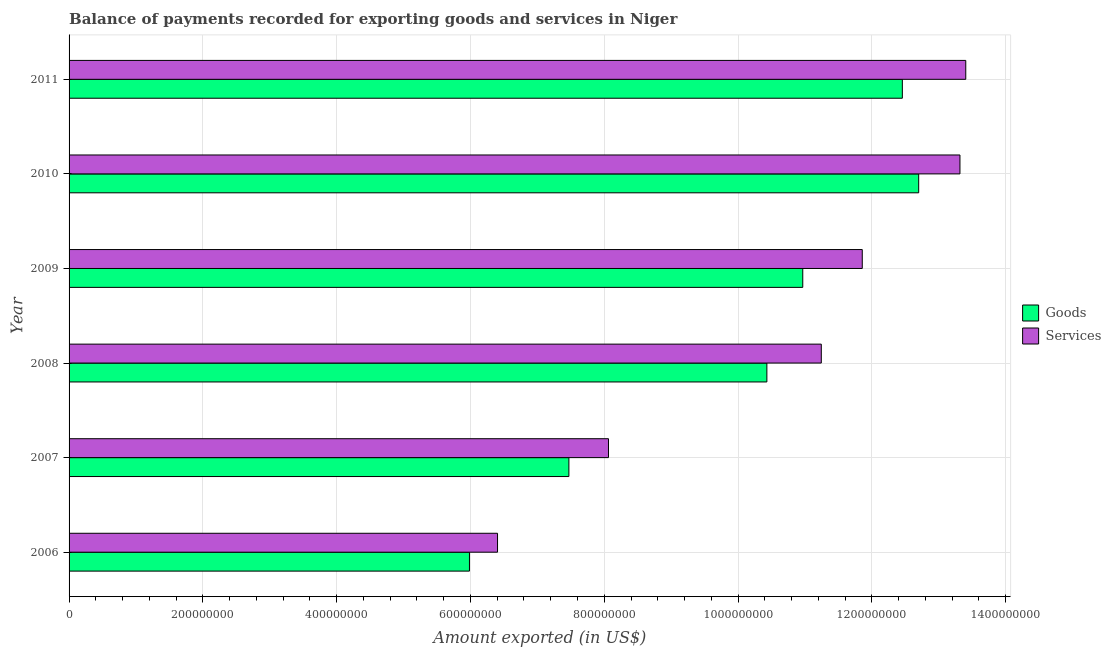How many different coloured bars are there?
Your answer should be compact. 2. How many groups of bars are there?
Your response must be concise. 6. Are the number of bars per tick equal to the number of legend labels?
Ensure brevity in your answer.  Yes. What is the amount of goods exported in 2007?
Your answer should be very brief. 7.47e+08. Across all years, what is the maximum amount of services exported?
Keep it short and to the point. 1.34e+09. Across all years, what is the minimum amount of goods exported?
Give a very brief answer. 5.99e+08. In which year was the amount of services exported minimum?
Provide a short and direct response. 2006. What is the total amount of services exported in the graph?
Give a very brief answer. 6.43e+09. What is the difference between the amount of services exported in 2007 and that in 2011?
Keep it short and to the point. -5.34e+08. What is the difference between the amount of services exported in 2006 and the amount of goods exported in 2011?
Provide a short and direct response. -6.05e+08. What is the average amount of goods exported per year?
Provide a succinct answer. 1.00e+09. In the year 2008, what is the difference between the amount of goods exported and amount of services exported?
Ensure brevity in your answer.  -8.13e+07. What is the ratio of the amount of services exported in 2007 to that in 2008?
Your answer should be very brief. 0.72. Is the difference between the amount of services exported in 2008 and 2009 greater than the difference between the amount of goods exported in 2008 and 2009?
Provide a succinct answer. No. What is the difference between the highest and the second highest amount of services exported?
Your answer should be very brief. 8.69e+06. What is the difference between the highest and the lowest amount of goods exported?
Provide a short and direct response. 6.72e+08. What does the 1st bar from the top in 2009 represents?
Provide a short and direct response. Services. What does the 1st bar from the bottom in 2009 represents?
Your answer should be very brief. Goods. How many bars are there?
Offer a very short reply. 12. Are all the bars in the graph horizontal?
Ensure brevity in your answer.  Yes. Does the graph contain any zero values?
Give a very brief answer. No. Does the graph contain grids?
Offer a very short reply. Yes. How many legend labels are there?
Provide a succinct answer. 2. What is the title of the graph?
Give a very brief answer. Balance of payments recorded for exporting goods and services in Niger. Does "Agricultural land" appear as one of the legend labels in the graph?
Give a very brief answer. No. What is the label or title of the X-axis?
Give a very brief answer. Amount exported (in US$). What is the label or title of the Y-axis?
Provide a succinct answer. Year. What is the Amount exported (in US$) of Goods in 2006?
Offer a very short reply. 5.99e+08. What is the Amount exported (in US$) of Services in 2006?
Your answer should be very brief. 6.40e+08. What is the Amount exported (in US$) in Goods in 2007?
Keep it short and to the point. 7.47e+08. What is the Amount exported (in US$) in Services in 2007?
Ensure brevity in your answer.  8.06e+08. What is the Amount exported (in US$) in Goods in 2008?
Provide a succinct answer. 1.04e+09. What is the Amount exported (in US$) in Services in 2008?
Ensure brevity in your answer.  1.12e+09. What is the Amount exported (in US$) in Goods in 2009?
Offer a very short reply. 1.10e+09. What is the Amount exported (in US$) in Services in 2009?
Your answer should be compact. 1.19e+09. What is the Amount exported (in US$) in Goods in 2010?
Provide a succinct answer. 1.27e+09. What is the Amount exported (in US$) in Services in 2010?
Your answer should be very brief. 1.33e+09. What is the Amount exported (in US$) of Goods in 2011?
Give a very brief answer. 1.25e+09. What is the Amount exported (in US$) of Services in 2011?
Offer a very short reply. 1.34e+09. Across all years, what is the maximum Amount exported (in US$) of Goods?
Ensure brevity in your answer.  1.27e+09. Across all years, what is the maximum Amount exported (in US$) in Services?
Give a very brief answer. 1.34e+09. Across all years, what is the minimum Amount exported (in US$) in Goods?
Keep it short and to the point. 5.99e+08. Across all years, what is the minimum Amount exported (in US$) of Services?
Keep it short and to the point. 6.40e+08. What is the total Amount exported (in US$) in Goods in the graph?
Offer a terse response. 6.00e+09. What is the total Amount exported (in US$) in Services in the graph?
Your answer should be compact. 6.43e+09. What is the difference between the Amount exported (in US$) of Goods in 2006 and that in 2007?
Give a very brief answer. -1.49e+08. What is the difference between the Amount exported (in US$) of Services in 2006 and that in 2007?
Offer a very short reply. -1.66e+08. What is the difference between the Amount exported (in US$) of Goods in 2006 and that in 2008?
Your answer should be very brief. -4.45e+08. What is the difference between the Amount exported (in US$) of Services in 2006 and that in 2008?
Provide a short and direct response. -4.84e+08. What is the difference between the Amount exported (in US$) in Goods in 2006 and that in 2009?
Provide a succinct answer. -4.98e+08. What is the difference between the Amount exported (in US$) of Services in 2006 and that in 2009?
Offer a very short reply. -5.45e+08. What is the difference between the Amount exported (in US$) of Goods in 2006 and that in 2010?
Your response must be concise. -6.72e+08. What is the difference between the Amount exported (in US$) of Services in 2006 and that in 2010?
Keep it short and to the point. -6.91e+08. What is the difference between the Amount exported (in US$) of Goods in 2006 and that in 2011?
Provide a succinct answer. -6.47e+08. What is the difference between the Amount exported (in US$) of Services in 2006 and that in 2011?
Your answer should be very brief. -7.00e+08. What is the difference between the Amount exported (in US$) in Goods in 2007 and that in 2008?
Offer a terse response. -2.96e+08. What is the difference between the Amount exported (in US$) of Services in 2007 and that in 2008?
Provide a succinct answer. -3.18e+08. What is the difference between the Amount exported (in US$) in Goods in 2007 and that in 2009?
Give a very brief answer. -3.50e+08. What is the difference between the Amount exported (in US$) of Services in 2007 and that in 2009?
Your response must be concise. -3.79e+08. What is the difference between the Amount exported (in US$) in Goods in 2007 and that in 2010?
Your answer should be compact. -5.23e+08. What is the difference between the Amount exported (in US$) of Services in 2007 and that in 2010?
Make the answer very short. -5.25e+08. What is the difference between the Amount exported (in US$) in Goods in 2007 and that in 2011?
Your answer should be compact. -4.98e+08. What is the difference between the Amount exported (in US$) of Services in 2007 and that in 2011?
Provide a succinct answer. -5.34e+08. What is the difference between the Amount exported (in US$) of Goods in 2008 and that in 2009?
Ensure brevity in your answer.  -5.36e+07. What is the difference between the Amount exported (in US$) of Services in 2008 and that in 2009?
Your answer should be very brief. -6.12e+07. What is the difference between the Amount exported (in US$) in Goods in 2008 and that in 2010?
Offer a very short reply. -2.27e+08. What is the difference between the Amount exported (in US$) of Services in 2008 and that in 2010?
Offer a terse response. -2.07e+08. What is the difference between the Amount exported (in US$) of Goods in 2008 and that in 2011?
Your answer should be very brief. -2.03e+08. What is the difference between the Amount exported (in US$) in Services in 2008 and that in 2011?
Make the answer very short. -2.16e+08. What is the difference between the Amount exported (in US$) of Goods in 2009 and that in 2010?
Offer a very short reply. -1.73e+08. What is the difference between the Amount exported (in US$) in Services in 2009 and that in 2010?
Ensure brevity in your answer.  -1.46e+08. What is the difference between the Amount exported (in US$) of Goods in 2009 and that in 2011?
Your response must be concise. -1.49e+08. What is the difference between the Amount exported (in US$) in Services in 2009 and that in 2011?
Make the answer very short. -1.55e+08. What is the difference between the Amount exported (in US$) of Goods in 2010 and that in 2011?
Offer a terse response. 2.44e+07. What is the difference between the Amount exported (in US$) of Services in 2010 and that in 2011?
Ensure brevity in your answer.  -8.69e+06. What is the difference between the Amount exported (in US$) in Goods in 2006 and the Amount exported (in US$) in Services in 2007?
Provide a short and direct response. -2.08e+08. What is the difference between the Amount exported (in US$) of Goods in 2006 and the Amount exported (in US$) of Services in 2008?
Keep it short and to the point. -5.26e+08. What is the difference between the Amount exported (in US$) in Goods in 2006 and the Amount exported (in US$) in Services in 2009?
Offer a very short reply. -5.87e+08. What is the difference between the Amount exported (in US$) of Goods in 2006 and the Amount exported (in US$) of Services in 2010?
Give a very brief answer. -7.33e+08. What is the difference between the Amount exported (in US$) of Goods in 2006 and the Amount exported (in US$) of Services in 2011?
Your response must be concise. -7.42e+08. What is the difference between the Amount exported (in US$) of Goods in 2007 and the Amount exported (in US$) of Services in 2008?
Give a very brief answer. -3.77e+08. What is the difference between the Amount exported (in US$) of Goods in 2007 and the Amount exported (in US$) of Services in 2009?
Make the answer very short. -4.39e+08. What is the difference between the Amount exported (in US$) of Goods in 2007 and the Amount exported (in US$) of Services in 2010?
Make the answer very short. -5.85e+08. What is the difference between the Amount exported (in US$) of Goods in 2007 and the Amount exported (in US$) of Services in 2011?
Offer a terse response. -5.93e+08. What is the difference between the Amount exported (in US$) of Goods in 2008 and the Amount exported (in US$) of Services in 2009?
Offer a terse response. -1.43e+08. What is the difference between the Amount exported (in US$) of Goods in 2008 and the Amount exported (in US$) of Services in 2010?
Keep it short and to the point. -2.89e+08. What is the difference between the Amount exported (in US$) of Goods in 2008 and the Amount exported (in US$) of Services in 2011?
Provide a short and direct response. -2.97e+08. What is the difference between the Amount exported (in US$) of Goods in 2009 and the Amount exported (in US$) of Services in 2010?
Provide a succinct answer. -2.35e+08. What is the difference between the Amount exported (in US$) in Goods in 2009 and the Amount exported (in US$) in Services in 2011?
Provide a short and direct response. -2.44e+08. What is the difference between the Amount exported (in US$) in Goods in 2010 and the Amount exported (in US$) in Services in 2011?
Your answer should be compact. -7.04e+07. What is the average Amount exported (in US$) of Goods per year?
Keep it short and to the point. 1.00e+09. What is the average Amount exported (in US$) in Services per year?
Your answer should be compact. 1.07e+09. In the year 2006, what is the difference between the Amount exported (in US$) in Goods and Amount exported (in US$) in Services?
Your answer should be very brief. -4.20e+07. In the year 2007, what is the difference between the Amount exported (in US$) in Goods and Amount exported (in US$) in Services?
Offer a very short reply. -5.92e+07. In the year 2008, what is the difference between the Amount exported (in US$) of Goods and Amount exported (in US$) of Services?
Offer a terse response. -8.13e+07. In the year 2009, what is the difference between the Amount exported (in US$) of Goods and Amount exported (in US$) of Services?
Your answer should be very brief. -8.89e+07. In the year 2010, what is the difference between the Amount exported (in US$) of Goods and Amount exported (in US$) of Services?
Ensure brevity in your answer.  -6.17e+07. In the year 2011, what is the difference between the Amount exported (in US$) of Goods and Amount exported (in US$) of Services?
Provide a succinct answer. -9.48e+07. What is the ratio of the Amount exported (in US$) in Goods in 2006 to that in 2007?
Your answer should be compact. 0.8. What is the ratio of the Amount exported (in US$) in Services in 2006 to that in 2007?
Your answer should be compact. 0.79. What is the ratio of the Amount exported (in US$) of Goods in 2006 to that in 2008?
Give a very brief answer. 0.57. What is the ratio of the Amount exported (in US$) of Services in 2006 to that in 2008?
Provide a short and direct response. 0.57. What is the ratio of the Amount exported (in US$) of Goods in 2006 to that in 2009?
Offer a terse response. 0.55. What is the ratio of the Amount exported (in US$) in Services in 2006 to that in 2009?
Your answer should be very brief. 0.54. What is the ratio of the Amount exported (in US$) of Goods in 2006 to that in 2010?
Ensure brevity in your answer.  0.47. What is the ratio of the Amount exported (in US$) of Services in 2006 to that in 2010?
Provide a short and direct response. 0.48. What is the ratio of the Amount exported (in US$) in Goods in 2006 to that in 2011?
Give a very brief answer. 0.48. What is the ratio of the Amount exported (in US$) in Services in 2006 to that in 2011?
Your response must be concise. 0.48. What is the ratio of the Amount exported (in US$) in Goods in 2007 to that in 2008?
Provide a short and direct response. 0.72. What is the ratio of the Amount exported (in US$) of Services in 2007 to that in 2008?
Ensure brevity in your answer.  0.72. What is the ratio of the Amount exported (in US$) in Goods in 2007 to that in 2009?
Offer a very short reply. 0.68. What is the ratio of the Amount exported (in US$) of Services in 2007 to that in 2009?
Ensure brevity in your answer.  0.68. What is the ratio of the Amount exported (in US$) of Goods in 2007 to that in 2010?
Give a very brief answer. 0.59. What is the ratio of the Amount exported (in US$) in Services in 2007 to that in 2010?
Make the answer very short. 0.61. What is the ratio of the Amount exported (in US$) of Goods in 2007 to that in 2011?
Ensure brevity in your answer.  0.6. What is the ratio of the Amount exported (in US$) in Services in 2007 to that in 2011?
Your answer should be compact. 0.6. What is the ratio of the Amount exported (in US$) of Goods in 2008 to that in 2009?
Make the answer very short. 0.95. What is the ratio of the Amount exported (in US$) of Services in 2008 to that in 2009?
Keep it short and to the point. 0.95. What is the ratio of the Amount exported (in US$) of Goods in 2008 to that in 2010?
Keep it short and to the point. 0.82. What is the ratio of the Amount exported (in US$) of Services in 2008 to that in 2010?
Give a very brief answer. 0.84. What is the ratio of the Amount exported (in US$) in Goods in 2008 to that in 2011?
Provide a short and direct response. 0.84. What is the ratio of the Amount exported (in US$) of Services in 2008 to that in 2011?
Make the answer very short. 0.84. What is the ratio of the Amount exported (in US$) in Goods in 2009 to that in 2010?
Ensure brevity in your answer.  0.86. What is the ratio of the Amount exported (in US$) in Services in 2009 to that in 2010?
Offer a very short reply. 0.89. What is the ratio of the Amount exported (in US$) of Goods in 2009 to that in 2011?
Keep it short and to the point. 0.88. What is the ratio of the Amount exported (in US$) of Services in 2009 to that in 2011?
Provide a short and direct response. 0.88. What is the ratio of the Amount exported (in US$) of Goods in 2010 to that in 2011?
Make the answer very short. 1.02. What is the ratio of the Amount exported (in US$) of Services in 2010 to that in 2011?
Your answer should be very brief. 0.99. What is the difference between the highest and the second highest Amount exported (in US$) of Goods?
Ensure brevity in your answer.  2.44e+07. What is the difference between the highest and the second highest Amount exported (in US$) in Services?
Offer a very short reply. 8.69e+06. What is the difference between the highest and the lowest Amount exported (in US$) of Goods?
Your response must be concise. 6.72e+08. What is the difference between the highest and the lowest Amount exported (in US$) of Services?
Provide a short and direct response. 7.00e+08. 